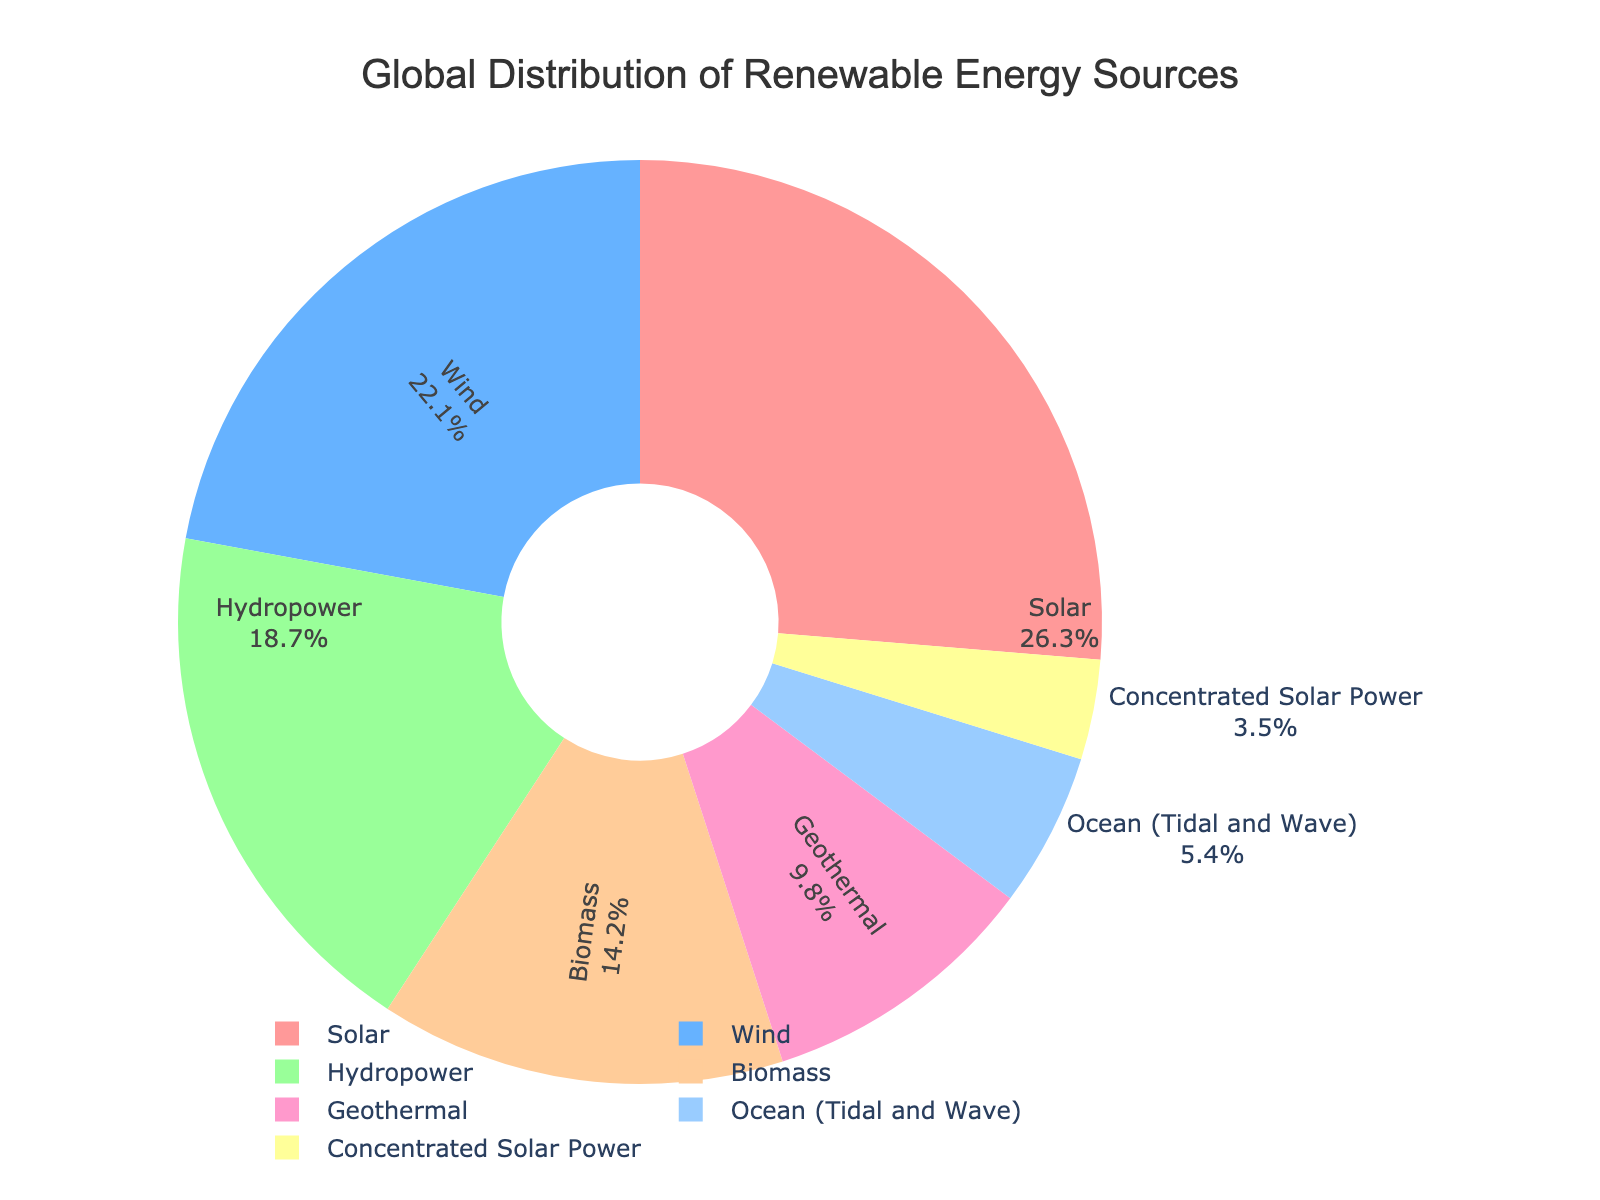Which renewable energy source has the highest percentage in the global distribution? The figure shows a pie chart divided into sections representing different renewable energy sources. The largest section is labeled "Solar" with a percentage of 26.3%.
Answer: Solar What is the combined percentage of Wind and Hydropower energy sources? The pie chart shows that Wind has a percentage of 22.1% and Hydropower has 18.7%. Adding these together, 22.1% + 18.7% = 40.8%.
Answer: 40.8% Is Biomass energy more prevalent than Geothermal energy globally? By looking at the pie chart, Biomass has a percentage of 14.2% while Geothermal has 9.8%. Since 14.2% is greater than 9.8%, Biomass is more prevalent than Geothermal.
Answer: Yes Which three renewable energy sources combined make up over half of the global distribution? The top three percentages from the pie chart are Solar (26.3%), Wind (22.1%), and Hydropower (18.7%). Adding these, 26.3% + 22.1% + 18.7% = 67.1%, which is over half (50%).
Answer: Solar, Wind, Hydropower How much greater is the percentage of Ocean (Tidal and Wave) energy compared to Concentrated Solar Power? The figure lists Ocean (Tidal and Wave) at 5.4% and Concentrated Solar Power at 3.5%. The difference is 5.4% - 3.5% = 1.9%.
Answer: 1.9% What percentage of global renewable energy comes from sources other than Solar, Wind, and Hydropower? Combining the three large sources: Solar (26.3%), Wind (22.1%), and Hydropower (18.7%), the total is 67.1%. Subtracting this from 100% gives 100% - 67.1% = 32.9%.
Answer: 32.9% Which energy source has the smallest representation in the global renewable energy distribution? From the pie chart, Concentrated Solar Power has the smallest percentage at 3.5%.
Answer: Concentrated Solar Power What is the total percentage represented by the bottom three renewable energy sources? The bottom three sources are Geothermal (9.8%), Ocean (Tidal and Wave) (5.4%), and Concentrated Solar Power (3.5%). Summing these, 9.8% + 5.4% + 3.5% = 18.7%.
Answer: 18.7% How many more percentage points does Solar contribute compared to Biomass? Solar has a percentage of 26.3% and Biomass has 14.2%. The difference is 26.3% - 14.2% = 12.1%.
Answer: 12.1% 